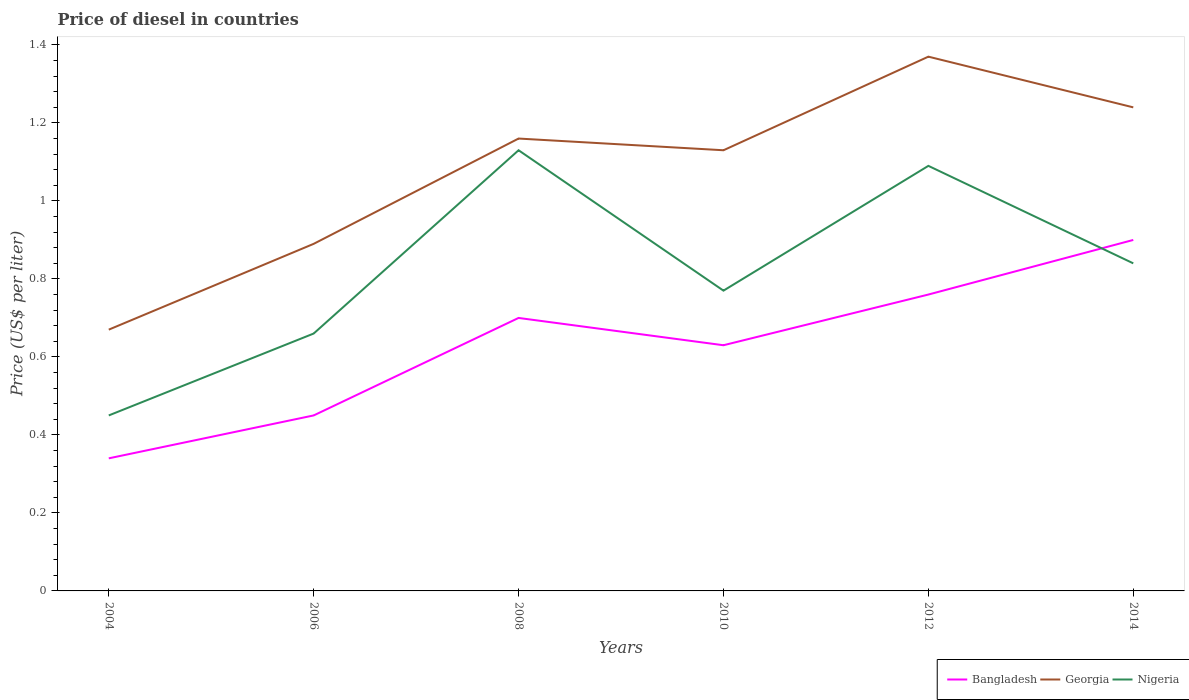Does the line corresponding to Nigeria intersect with the line corresponding to Georgia?
Make the answer very short. No. Across all years, what is the maximum price of diesel in Georgia?
Your answer should be compact. 0.67. In which year was the price of diesel in Nigeria maximum?
Keep it short and to the point. 2004. What is the total price of diesel in Georgia in the graph?
Make the answer very short. 0.03. What is the difference between the highest and the second highest price of diesel in Nigeria?
Your answer should be very brief. 0.68. What is the difference between the highest and the lowest price of diesel in Georgia?
Your answer should be compact. 4. Is the price of diesel in Nigeria strictly greater than the price of diesel in Georgia over the years?
Provide a short and direct response. Yes. How many lines are there?
Make the answer very short. 3. How many years are there in the graph?
Give a very brief answer. 6. Are the values on the major ticks of Y-axis written in scientific E-notation?
Your answer should be very brief. No. Does the graph contain any zero values?
Offer a very short reply. No. Does the graph contain grids?
Offer a terse response. No. Where does the legend appear in the graph?
Make the answer very short. Bottom right. What is the title of the graph?
Keep it short and to the point. Price of diesel in countries. What is the label or title of the Y-axis?
Give a very brief answer. Price (US$ per liter). What is the Price (US$ per liter) of Bangladesh in 2004?
Provide a succinct answer. 0.34. What is the Price (US$ per liter) in Georgia in 2004?
Your answer should be very brief. 0.67. What is the Price (US$ per liter) in Nigeria in 2004?
Your response must be concise. 0.45. What is the Price (US$ per liter) in Bangladesh in 2006?
Ensure brevity in your answer.  0.45. What is the Price (US$ per liter) in Georgia in 2006?
Keep it short and to the point. 0.89. What is the Price (US$ per liter) in Nigeria in 2006?
Provide a short and direct response. 0.66. What is the Price (US$ per liter) of Georgia in 2008?
Your response must be concise. 1.16. What is the Price (US$ per liter) in Nigeria in 2008?
Give a very brief answer. 1.13. What is the Price (US$ per liter) in Bangladesh in 2010?
Your answer should be compact. 0.63. What is the Price (US$ per liter) in Georgia in 2010?
Provide a succinct answer. 1.13. What is the Price (US$ per liter) of Nigeria in 2010?
Ensure brevity in your answer.  0.77. What is the Price (US$ per liter) of Bangladesh in 2012?
Your answer should be compact. 0.76. What is the Price (US$ per liter) in Georgia in 2012?
Your answer should be very brief. 1.37. What is the Price (US$ per liter) in Nigeria in 2012?
Your response must be concise. 1.09. What is the Price (US$ per liter) in Georgia in 2014?
Make the answer very short. 1.24. What is the Price (US$ per liter) in Nigeria in 2014?
Offer a very short reply. 0.84. Across all years, what is the maximum Price (US$ per liter) of Bangladesh?
Provide a succinct answer. 0.9. Across all years, what is the maximum Price (US$ per liter) of Georgia?
Make the answer very short. 1.37. Across all years, what is the maximum Price (US$ per liter) in Nigeria?
Keep it short and to the point. 1.13. Across all years, what is the minimum Price (US$ per liter) in Bangladesh?
Offer a very short reply. 0.34. Across all years, what is the minimum Price (US$ per liter) of Georgia?
Ensure brevity in your answer.  0.67. Across all years, what is the minimum Price (US$ per liter) of Nigeria?
Provide a succinct answer. 0.45. What is the total Price (US$ per liter) of Bangladesh in the graph?
Provide a short and direct response. 3.78. What is the total Price (US$ per liter) of Georgia in the graph?
Ensure brevity in your answer.  6.46. What is the total Price (US$ per liter) of Nigeria in the graph?
Your response must be concise. 4.94. What is the difference between the Price (US$ per liter) of Bangladesh in 2004 and that in 2006?
Provide a succinct answer. -0.11. What is the difference between the Price (US$ per liter) in Georgia in 2004 and that in 2006?
Your answer should be compact. -0.22. What is the difference between the Price (US$ per liter) in Nigeria in 2004 and that in 2006?
Ensure brevity in your answer.  -0.21. What is the difference between the Price (US$ per liter) of Bangladesh in 2004 and that in 2008?
Your answer should be compact. -0.36. What is the difference between the Price (US$ per liter) of Georgia in 2004 and that in 2008?
Your answer should be compact. -0.49. What is the difference between the Price (US$ per liter) in Nigeria in 2004 and that in 2008?
Your answer should be very brief. -0.68. What is the difference between the Price (US$ per liter) of Bangladesh in 2004 and that in 2010?
Offer a terse response. -0.29. What is the difference between the Price (US$ per liter) of Georgia in 2004 and that in 2010?
Your response must be concise. -0.46. What is the difference between the Price (US$ per liter) in Nigeria in 2004 and that in 2010?
Provide a succinct answer. -0.32. What is the difference between the Price (US$ per liter) in Bangladesh in 2004 and that in 2012?
Offer a terse response. -0.42. What is the difference between the Price (US$ per liter) in Georgia in 2004 and that in 2012?
Provide a short and direct response. -0.7. What is the difference between the Price (US$ per liter) in Nigeria in 2004 and that in 2012?
Make the answer very short. -0.64. What is the difference between the Price (US$ per liter) in Bangladesh in 2004 and that in 2014?
Provide a succinct answer. -0.56. What is the difference between the Price (US$ per liter) of Georgia in 2004 and that in 2014?
Ensure brevity in your answer.  -0.57. What is the difference between the Price (US$ per liter) in Nigeria in 2004 and that in 2014?
Your answer should be compact. -0.39. What is the difference between the Price (US$ per liter) in Georgia in 2006 and that in 2008?
Your response must be concise. -0.27. What is the difference between the Price (US$ per liter) of Nigeria in 2006 and that in 2008?
Your answer should be compact. -0.47. What is the difference between the Price (US$ per liter) in Bangladesh in 2006 and that in 2010?
Your answer should be very brief. -0.18. What is the difference between the Price (US$ per liter) in Georgia in 2006 and that in 2010?
Provide a short and direct response. -0.24. What is the difference between the Price (US$ per liter) in Nigeria in 2006 and that in 2010?
Offer a very short reply. -0.11. What is the difference between the Price (US$ per liter) in Bangladesh in 2006 and that in 2012?
Offer a very short reply. -0.31. What is the difference between the Price (US$ per liter) of Georgia in 2006 and that in 2012?
Your response must be concise. -0.48. What is the difference between the Price (US$ per liter) of Nigeria in 2006 and that in 2012?
Keep it short and to the point. -0.43. What is the difference between the Price (US$ per liter) of Bangladesh in 2006 and that in 2014?
Your answer should be compact. -0.45. What is the difference between the Price (US$ per liter) of Georgia in 2006 and that in 2014?
Give a very brief answer. -0.35. What is the difference between the Price (US$ per liter) in Nigeria in 2006 and that in 2014?
Keep it short and to the point. -0.18. What is the difference between the Price (US$ per liter) in Bangladesh in 2008 and that in 2010?
Provide a succinct answer. 0.07. What is the difference between the Price (US$ per liter) of Nigeria in 2008 and that in 2010?
Your response must be concise. 0.36. What is the difference between the Price (US$ per liter) in Bangladesh in 2008 and that in 2012?
Make the answer very short. -0.06. What is the difference between the Price (US$ per liter) in Georgia in 2008 and that in 2012?
Offer a terse response. -0.21. What is the difference between the Price (US$ per liter) of Georgia in 2008 and that in 2014?
Your answer should be compact. -0.08. What is the difference between the Price (US$ per liter) in Nigeria in 2008 and that in 2014?
Your answer should be compact. 0.29. What is the difference between the Price (US$ per liter) of Bangladesh in 2010 and that in 2012?
Ensure brevity in your answer.  -0.13. What is the difference between the Price (US$ per liter) in Georgia in 2010 and that in 2012?
Give a very brief answer. -0.24. What is the difference between the Price (US$ per liter) of Nigeria in 2010 and that in 2012?
Offer a terse response. -0.32. What is the difference between the Price (US$ per liter) in Bangladesh in 2010 and that in 2014?
Your answer should be compact. -0.27. What is the difference between the Price (US$ per liter) in Georgia in 2010 and that in 2014?
Provide a succinct answer. -0.11. What is the difference between the Price (US$ per liter) in Nigeria in 2010 and that in 2014?
Your response must be concise. -0.07. What is the difference between the Price (US$ per liter) in Bangladesh in 2012 and that in 2014?
Make the answer very short. -0.14. What is the difference between the Price (US$ per liter) in Georgia in 2012 and that in 2014?
Provide a succinct answer. 0.13. What is the difference between the Price (US$ per liter) of Bangladesh in 2004 and the Price (US$ per liter) of Georgia in 2006?
Your answer should be very brief. -0.55. What is the difference between the Price (US$ per liter) of Bangladesh in 2004 and the Price (US$ per liter) of Nigeria in 2006?
Your answer should be very brief. -0.32. What is the difference between the Price (US$ per liter) in Georgia in 2004 and the Price (US$ per liter) in Nigeria in 2006?
Your response must be concise. 0.01. What is the difference between the Price (US$ per liter) of Bangladesh in 2004 and the Price (US$ per liter) of Georgia in 2008?
Keep it short and to the point. -0.82. What is the difference between the Price (US$ per liter) in Bangladesh in 2004 and the Price (US$ per liter) in Nigeria in 2008?
Provide a succinct answer. -0.79. What is the difference between the Price (US$ per liter) in Georgia in 2004 and the Price (US$ per liter) in Nigeria in 2008?
Ensure brevity in your answer.  -0.46. What is the difference between the Price (US$ per liter) of Bangladesh in 2004 and the Price (US$ per liter) of Georgia in 2010?
Your answer should be very brief. -0.79. What is the difference between the Price (US$ per liter) in Bangladesh in 2004 and the Price (US$ per liter) in Nigeria in 2010?
Offer a very short reply. -0.43. What is the difference between the Price (US$ per liter) of Georgia in 2004 and the Price (US$ per liter) of Nigeria in 2010?
Provide a succinct answer. -0.1. What is the difference between the Price (US$ per liter) in Bangladesh in 2004 and the Price (US$ per liter) in Georgia in 2012?
Provide a succinct answer. -1.03. What is the difference between the Price (US$ per liter) of Bangladesh in 2004 and the Price (US$ per liter) of Nigeria in 2012?
Ensure brevity in your answer.  -0.75. What is the difference between the Price (US$ per liter) of Georgia in 2004 and the Price (US$ per liter) of Nigeria in 2012?
Your response must be concise. -0.42. What is the difference between the Price (US$ per liter) of Bangladesh in 2004 and the Price (US$ per liter) of Nigeria in 2014?
Your answer should be compact. -0.5. What is the difference between the Price (US$ per liter) of Georgia in 2004 and the Price (US$ per liter) of Nigeria in 2014?
Offer a terse response. -0.17. What is the difference between the Price (US$ per liter) of Bangladesh in 2006 and the Price (US$ per liter) of Georgia in 2008?
Your answer should be compact. -0.71. What is the difference between the Price (US$ per liter) of Bangladesh in 2006 and the Price (US$ per liter) of Nigeria in 2008?
Offer a terse response. -0.68. What is the difference between the Price (US$ per liter) in Georgia in 2006 and the Price (US$ per liter) in Nigeria in 2008?
Your response must be concise. -0.24. What is the difference between the Price (US$ per liter) in Bangladesh in 2006 and the Price (US$ per liter) in Georgia in 2010?
Keep it short and to the point. -0.68. What is the difference between the Price (US$ per liter) in Bangladesh in 2006 and the Price (US$ per liter) in Nigeria in 2010?
Provide a succinct answer. -0.32. What is the difference between the Price (US$ per liter) in Georgia in 2006 and the Price (US$ per liter) in Nigeria in 2010?
Keep it short and to the point. 0.12. What is the difference between the Price (US$ per liter) in Bangladesh in 2006 and the Price (US$ per liter) in Georgia in 2012?
Ensure brevity in your answer.  -0.92. What is the difference between the Price (US$ per liter) in Bangladesh in 2006 and the Price (US$ per liter) in Nigeria in 2012?
Give a very brief answer. -0.64. What is the difference between the Price (US$ per liter) in Bangladesh in 2006 and the Price (US$ per liter) in Georgia in 2014?
Keep it short and to the point. -0.79. What is the difference between the Price (US$ per liter) of Bangladesh in 2006 and the Price (US$ per liter) of Nigeria in 2014?
Keep it short and to the point. -0.39. What is the difference between the Price (US$ per liter) of Bangladesh in 2008 and the Price (US$ per liter) of Georgia in 2010?
Make the answer very short. -0.43. What is the difference between the Price (US$ per liter) in Bangladesh in 2008 and the Price (US$ per liter) in Nigeria in 2010?
Offer a very short reply. -0.07. What is the difference between the Price (US$ per liter) of Georgia in 2008 and the Price (US$ per liter) of Nigeria in 2010?
Give a very brief answer. 0.39. What is the difference between the Price (US$ per liter) of Bangladesh in 2008 and the Price (US$ per liter) of Georgia in 2012?
Provide a succinct answer. -0.67. What is the difference between the Price (US$ per liter) in Bangladesh in 2008 and the Price (US$ per liter) in Nigeria in 2012?
Keep it short and to the point. -0.39. What is the difference between the Price (US$ per liter) of Georgia in 2008 and the Price (US$ per liter) of Nigeria in 2012?
Keep it short and to the point. 0.07. What is the difference between the Price (US$ per liter) in Bangladesh in 2008 and the Price (US$ per liter) in Georgia in 2014?
Your response must be concise. -0.54. What is the difference between the Price (US$ per liter) of Bangladesh in 2008 and the Price (US$ per liter) of Nigeria in 2014?
Offer a terse response. -0.14. What is the difference between the Price (US$ per liter) of Georgia in 2008 and the Price (US$ per liter) of Nigeria in 2014?
Provide a short and direct response. 0.32. What is the difference between the Price (US$ per liter) in Bangladesh in 2010 and the Price (US$ per liter) in Georgia in 2012?
Your answer should be compact. -0.74. What is the difference between the Price (US$ per liter) of Bangladesh in 2010 and the Price (US$ per liter) of Nigeria in 2012?
Keep it short and to the point. -0.46. What is the difference between the Price (US$ per liter) in Georgia in 2010 and the Price (US$ per liter) in Nigeria in 2012?
Give a very brief answer. 0.04. What is the difference between the Price (US$ per liter) in Bangladesh in 2010 and the Price (US$ per liter) in Georgia in 2014?
Your answer should be compact. -0.61. What is the difference between the Price (US$ per liter) in Bangladesh in 2010 and the Price (US$ per liter) in Nigeria in 2014?
Provide a succinct answer. -0.21. What is the difference between the Price (US$ per liter) in Georgia in 2010 and the Price (US$ per liter) in Nigeria in 2014?
Keep it short and to the point. 0.29. What is the difference between the Price (US$ per liter) in Bangladesh in 2012 and the Price (US$ per liter) in Georgia in 2014?
Your response must be concise. -0.48. What is the difference between the Price (US$ per liter) of Bangladesh in 2012 and the Price (US$ per liter) of Nigeria in 2014?
Offer a terse response. -0.08. What is the difference between the Price (US$ per liter) in Georgia in 2012 and the Price (US$ per liter) in Nigeria in 2014?
Provide a short and direct response. 0.53. What is the average Price (US$ per liter) in Bangladesh per year?
Offer a terse response. 0.63. What is the average Price (US$ per liter) in Georgia per year?
Offer a very short reply. 1.08. What is the average Price (US$ per liter) in Nigeria per year?
Make the answer very short. 0.82. In the year 2004, what is the difference between the Price (US$ per liter) of Bangladesh and Price (US$ per liter) of Georgia?
Make the answer very short. -0.33. In the year 2004, what is the difference between the Price (US$ per liter) of Bangladesh and Price (US$ per liter) of Nigeria?
Keep it short and to the point. -0.11. In the year 2004, what is the difference between the Price (US$ per liter) of Georgia and Price (US$ per liter) of Nigeria?
Give a very brief answer. 0.22. In the year 2006, what is the difference between the Price (US$ per liter) in Bangladesh and Price (US$ per liter) in Georgia?
Give a very brief answer. -0.44. In the year 2006, what is the difference between the Price (US$ per liter) in Bangladesh and Price (US$ per liter) in Nigeria?
Your answer should be compact. -0.21. In the year 2006, what is the difference between the Price (US$ per liter) of Georgia and Price (US$ per liter) of Nigeria?
Provide a succinct answer. 0.23. In the year 2008, what is the difference between the Price (US$ per liter) in Bangladesh and Price (US$ per liter) in Georgia?
Your answer should be very brief. -0.46. In the year 2008, what is the difference between the Price (US$ per liter) in Bangladesh and Price (US$ per liter) in Nigeria?
Make the answer very short. -0.43. In the year 2008, what is the difference between the Price (US$ per liter) in Georgia and Price (US$ per liter) in Nigeria?
Ensure brevity in your answer.  0.03. In the year 2010, what is the difference between the Price (US$ per liter) in Bangladesh and Price (US$ per liter) in Nigeria?
Keep it short and to the point. -0.14. In the year 2010, what is the difference between the Price (US$ per liter) in Georgia and Price (US$ per liter) in Nigeria?
Your answer should be compact. 0.36. In the year 2012, what is the difference between the Price (US$ per liter) in Bangladesh and Price (US$ per liter) in Georgia?
Provide a short and direct response. -0.61. In the year 2012, what is the difference between the Price (US$ per liter) of Bangladesh and Price (US$ per liter) of Nigeria?
Provide a short and direct response. -0.33. In the year 2012, what is the difference between the Price (US$ per liter) of Georgia and Price (US$ per liter) of Nigeria?
Provide a short and direct response. 0.28. In the year 2014, what is the difference between the Price (US$ per liter) of Bangladesh and Price (US$ per liter) of Georgia?
Keep it short and to the point. -0.34. In the year 2014, what is the difference between the Price (US$ per liter) in Bangladesh and Price (US$ per liter) in Nigeria?
Provide a short and direct response. 0.06. In the year 2014, what is the difference between the Price (US$ per liter) in Georgia and Price (US$ per liter) in Nigeria?
Provide a succinct answer. 0.4. What is the ratio of the Price (US$ per liter) of Bangladesh in 2004 to that in 2006?
Your response must be concise. 0.76. What is the ratio of the Price (US$ per liter) of Georgia in 2004 to that in 2006?
Give a very brief answer. 0.75. What is the ratio of the Price (US$ per liter) of Nigeria in 2004 to that in 2006?
Ensure brevity in your answer.  0.68. What is the ratio of the Price (US$ per liter) in Bangladesh in 2004 to that in 2008?
Offer a terse response. 0.49. What is the ratio of the Price (US$ per liter) in Georgia in 2004 to that in 2008?
Provide a succinct answer. 0.58. What is the ratio of the Price (US$ per liter) in Nigeria in 2004 to that in 2008?
Provide a succinct answer. 0.4. What is the ratio of the Price (US$ per liter) in Bangladesh in 2004 to that in 2010?
Offer a terse response. 0.54. What is the ratio of the Price (US$ per liter) in Georgia in 2004 to that in 2010?
Your answer should be very brief. 0.59. What is the ratio of the Price (US$ per liter) of Nigeria in 2004 to that in 2010?
Offer a terse response. 0.58. What is the ratio of the Price (US$ per liter) in Bangladesh in 2004 to that in 2012?
Offer a terse response. 0.45. What is the ratio of the Price (US$ per liter) in Georgia in 2004 to that in 2012?
Ensure brevity in your answer.  0.49. What is the ratio of the Price (US$ per liter) in Nigeria in 2004 to that in 2012?
Ensure brevity in your answer.  0.41. What is the ratio of the Price (US$ per liter) in Bangladesh in 2004 to that in 2014?
Your answer should be very brief. 0.38. What is the ratio of the Price (US$ per liter) of Georgia in 2004 to that in 2014?
Give a very brief answer. 0.54. What is the ratio of the Price (US$ per liter) of Nigeria in 2004 to that in 2014?
Give a very brief answer. 0.54. What is the ratio of the Price (US$ per liter) in Bangladesh in 2006 to that in 2008?
Provide a succinct answer. 0.64. What is the ratio of the Price (US$ per liter) of Georgia in 2006 to that in 2008?
Provide a short and direct response. 0.77. What is the ratio of the Price (US$ per liter) in Nigeria in 2006 to that in 2008?
Provide a succinct answer. 0.58. What is the ratio of the Price (US$ per liter) of Bangladesh in 2006 to that in 2010?
Your answer should be very brief. 0.71. What is the ratio of the Price (US$ per liter) in Georgia in 2006 to that in 2010?
Offer a very short reply. 0.79. What is the ratio of the Price (US$ per liter) in Nigeria in 2006 to that in 2010?
Keep it short and to the point. 0.86. What is the ratio of the Price (US$ per liter) of Bangladesh in 2006 to that in 2012?
Your response must be concise. 0.59. What is the ratio of the Price (US$ per liter) in Georgia in 2006 to that in 2012?
Make the answer very short. 0.65. What is the ratio of the Price (US$ per liter) in Nigeria in 2006 to that in 2012?
Offer a terse response. 0.61. What is the ratio of the Price (US$ per liter) of Georgia in 2006 to that in 2014?
Ensure brevity in your answer.  0.72. What is the ratio of the Price (US$ per liter) of Nigeria in 2006 to that in 2014?
Your response must be concise. 0.79. What is the ratio of the Price (US$ per liter) of Georgia in 2008 to that in 2010?
Offer a terse response. 1.03. What is the ratio of the Price (US$ per liter) in Nigeria in 2008 to that in 2010?
Keep it short and to the point. 1.47. What is the ratio of the Price (US$ per liter) of Bangladesh in 2008 to that in 2012?
Provide a short and direct response. 0.92. What is the ratio of the Price (US$ per liter) of Georgia in 2008 to that in 2012?
Ensure brevity in your answer.  0.85. What is the ratio of the Price (US$ per liter) of Nigeria in 2008 to that in 2012?
Keep it short and to the point. 1.04. What is the ratio of the Price (US$ per liter) of Bangladesh in 2008 to that in 2014?
Keep it short and to the point. 0.78. What is the ratio of the Price (US$ per liter) in Georgia in 2008 to that in 2014?
Your response must be concise. 0.94. What is the ratio of the Price (US$ per liter) in Nigeria in 2008 to that in 2014?
Provide a short and direct response. 1.35. What is the ratio of the Price (US$ per liter) in Bangladesh in 2010 to that in 2012?
Give a very brief answer. 0.83. What is the ratio of the Price (US$ per liter) in Georgia in 2010 to that in 2012?
Provide a short and direct response. 0.82. What is the ratio of the Price (US$ per liter) in Nigeria in 2010 to that in 2012?
Offer a very short reply. 0.71. What is the ratio of the Price (US$ per liter) of Georgia in 2010 to that in 2014?
Your answer should be very brief. 0.91. What is the ratio of the Price (US$ per liter) in Nigeria in 2010 to that in 2014?
Give a very brief answer. 0.92. What is the ratio of the Price (US$ per liter) in Bangladesh in 2012 to that in 2014?
Provide a short and direct response. 0.84. What is the ratio of the Price (US$ per liter) of Georgia in 2012 to that in 2014?
Make the answer very short. 1.1. What is the ratio of the Price (US$ per liter) in Nigeria in 2012 to that in 2014?
Keep it short and to the point. 1.3. What is the difference between the highest and the second highest Price (US$ per liter) in Bangladesh?
Provide a short and direct response. 0.14. What is the difference between the highest and the second highest Price (US$ per liter) of Georgia?
Keep it short and to the point. 0.13. What is the difference between the highest and the second highest Price (US$ per liter) in Nigeria?
Your response must be concise. 0.04. What is the difference between the highest and the lowest Price (US$ per liter) in Bangladesh?
Offer a terse response. 0.56. What is the difference between the highest and the lowest Price (US$ per liter) of Nigeria?
Keep it short and to the point. 0.68. 